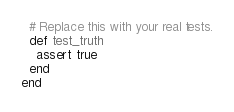<code> <loc_0><loc_0><loc_500><loc_500><_Ruby_>  # Replace this with your real tests.
  def test_truth
    assert true
  end
end
</code> 